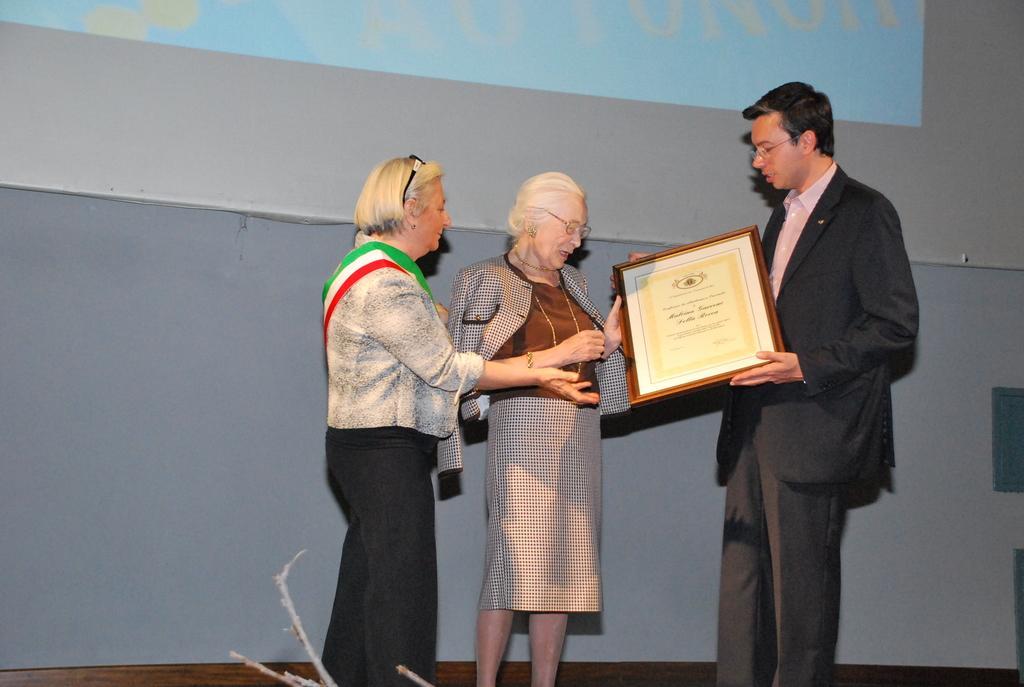Please provide a concise description of this image. In this image there are two people holding the award. Beside them there is another person. Behind them there is a screen. 